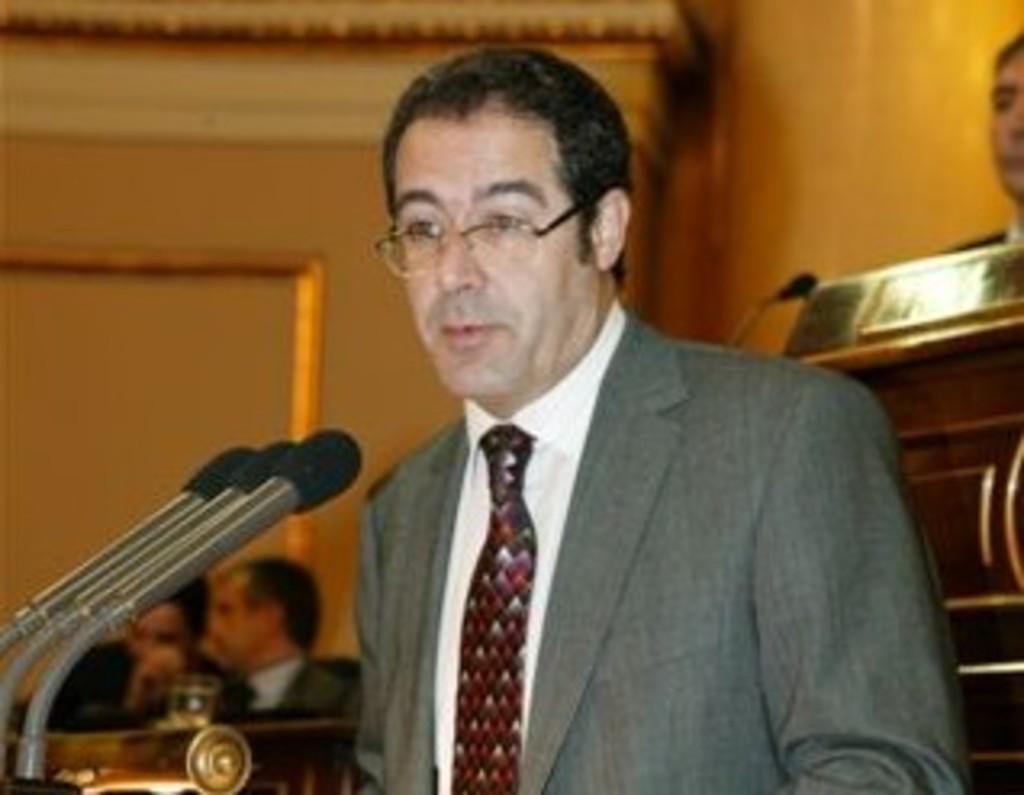Could you give a brief overview of what you see in this image? This picture describes about group of people, In the middle of the image we can see a man, he wore spectacles, in front of him we can see few microphones. 